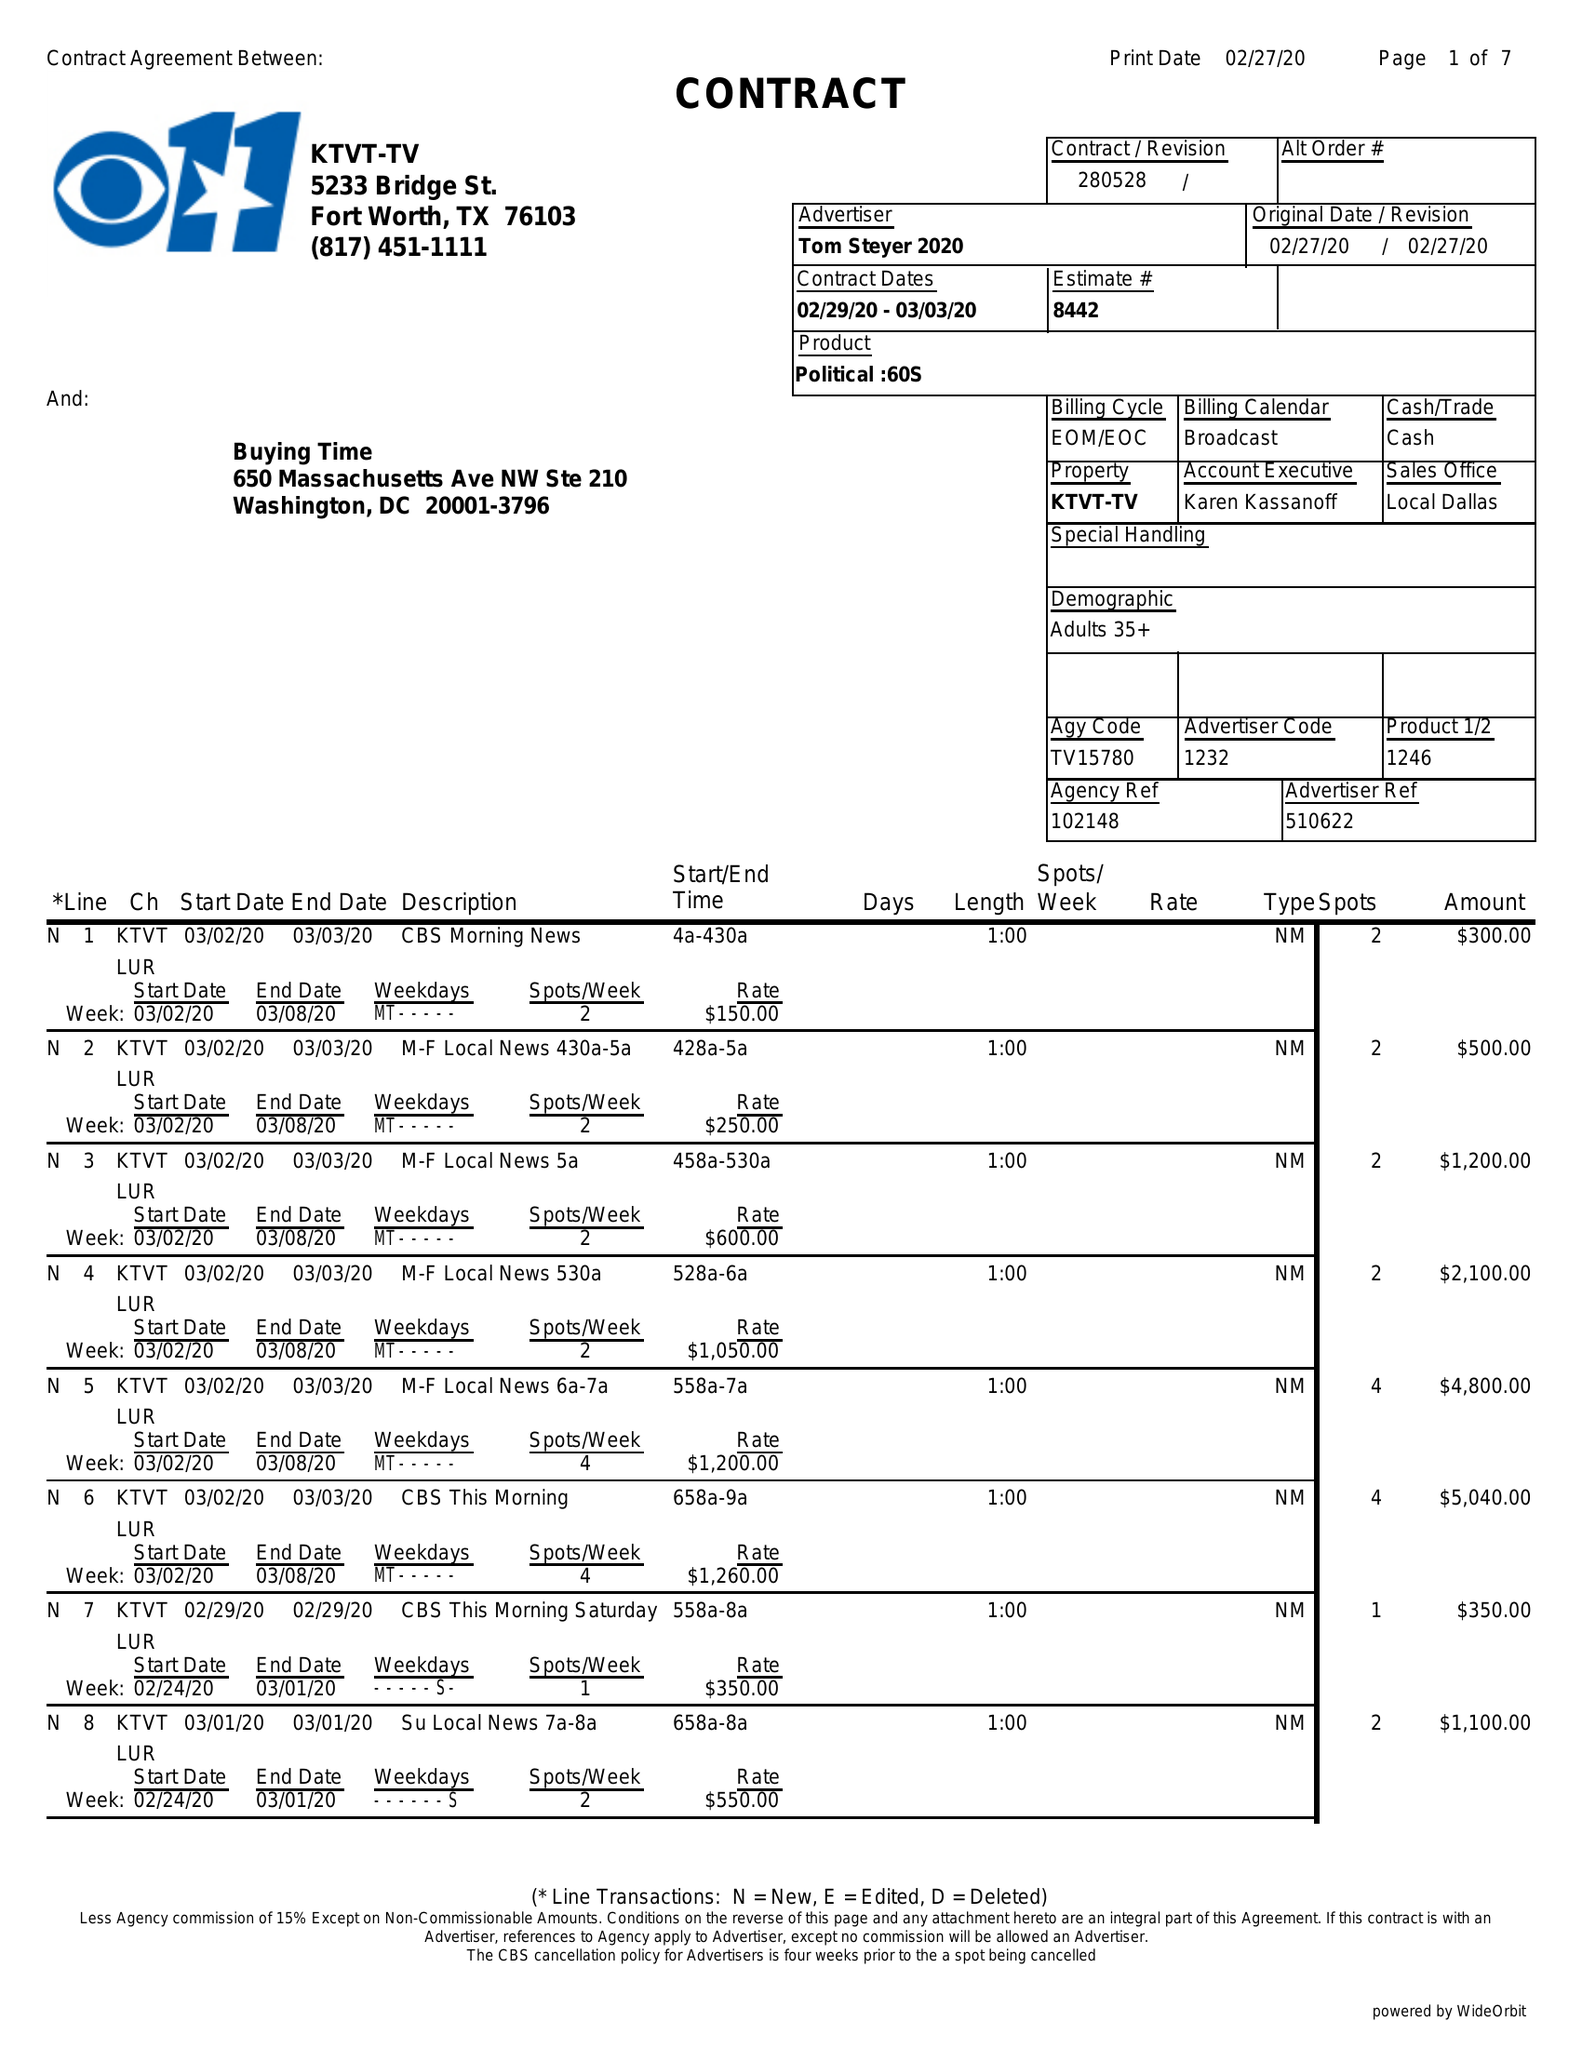What is the value for the gross_amount?
Answer the question using a single word or phrase. 180060.00 